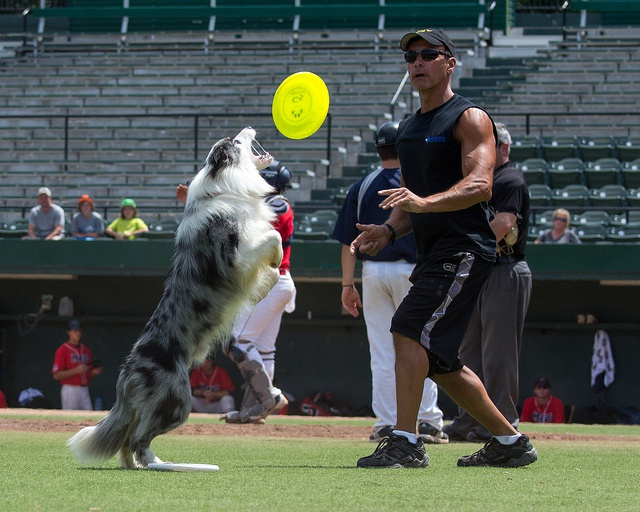Describe the objects in this image and their specific colors. I can see people in black, maroon, gray, and brown tones, dog in black, gray, darkgray, and lightgray tones, people in black, darkgray, and gray tones, people in black, gray, maroon, and darkgray tones, and people in black, darkgray, and gray tones in this image. 